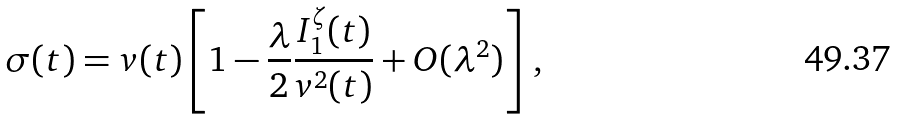Convert formula to latex. <formula><loc_0><loc_0><loc_500><loc_500>\sigma ( t ) = v ( t ) \left [ 1 - \frac { \lambda } { 2 } \frac { I _ { 1 } ^ { \zeta } ( t ) } { v ^ { 2 } ( t ) } + O ( \lambda ^ { 2 } ) \right ] \, ,</formula> 